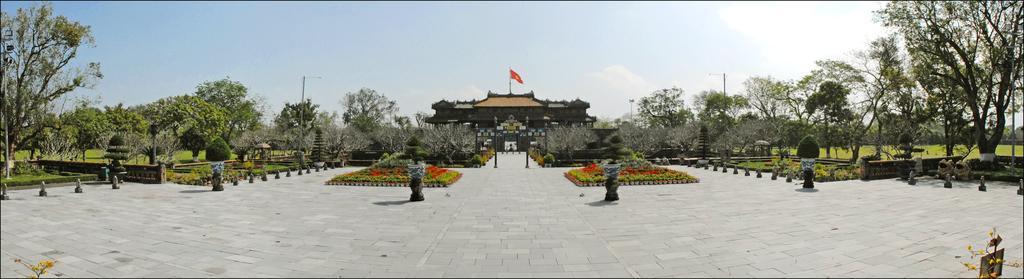Describe this image in one or two sentences. In this image we can see a house with flag. There are trees, plants, grass, flower pots. At the bottom of the image there is floor. At the top of the image there is sky. 